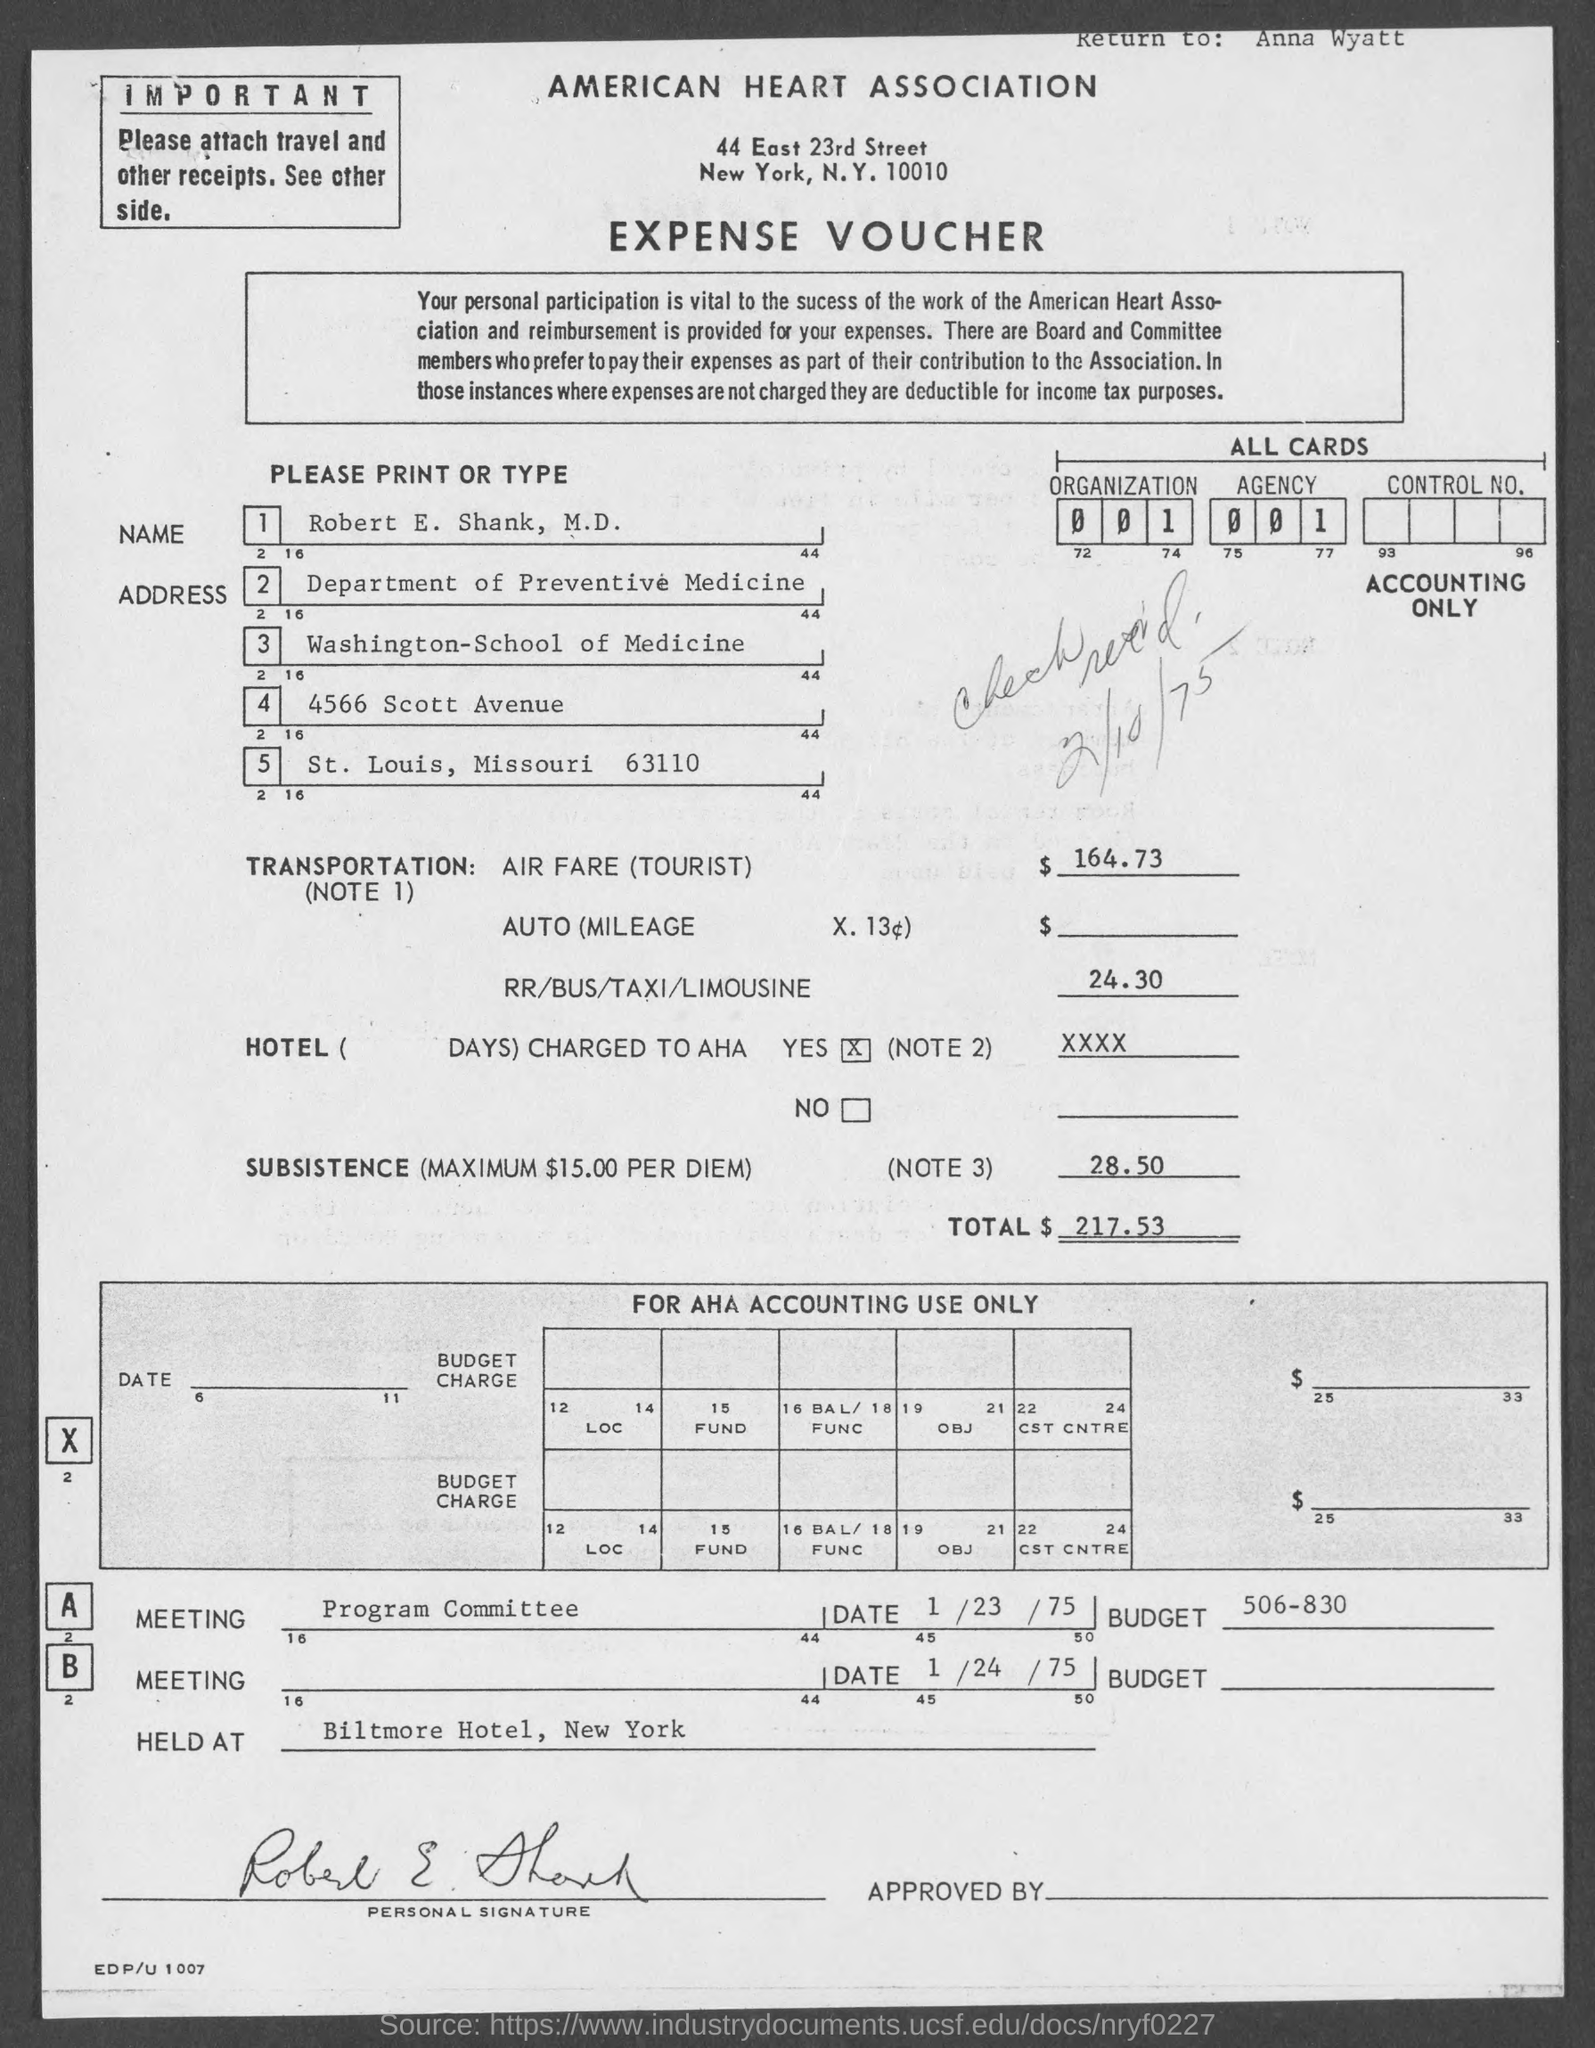Which association is mentioned?
Give a very brief answer. AMERICAN HEART ASSOCIATION. What type of documentation is this?
Your answer should be compact. EXPENSE VOUCHER. What is the amount of air fare (tourist)?
Keep it short and to the point. $ 164.73. When is the program committee meeting?
Provide a short and direct response. 1/23/75. 